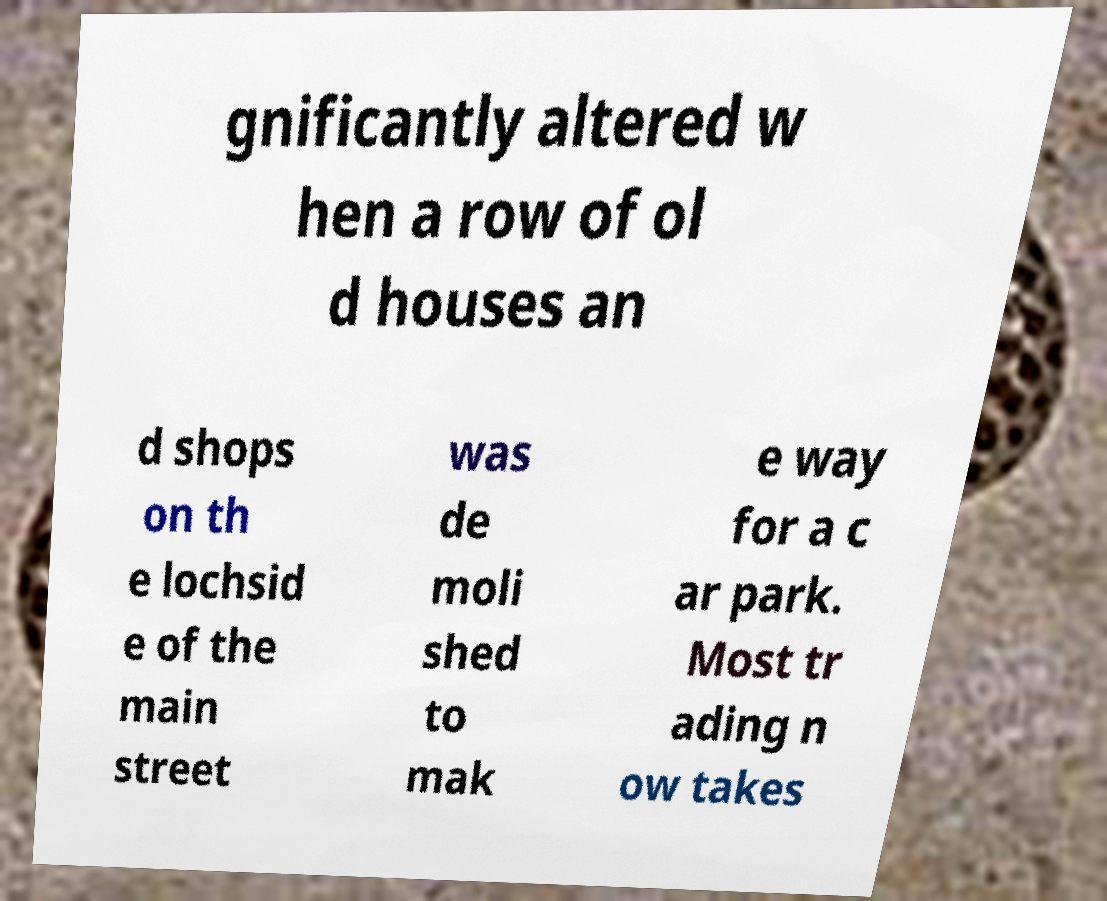What messages or text are displayed in this image? I need them in a readable, typed format. gnificantly altered w hen a row of ol d houses an d shops on th e lochsid e of the main street was de moli shed to mak e way for a c ar park. Most tr ading n ow takes 